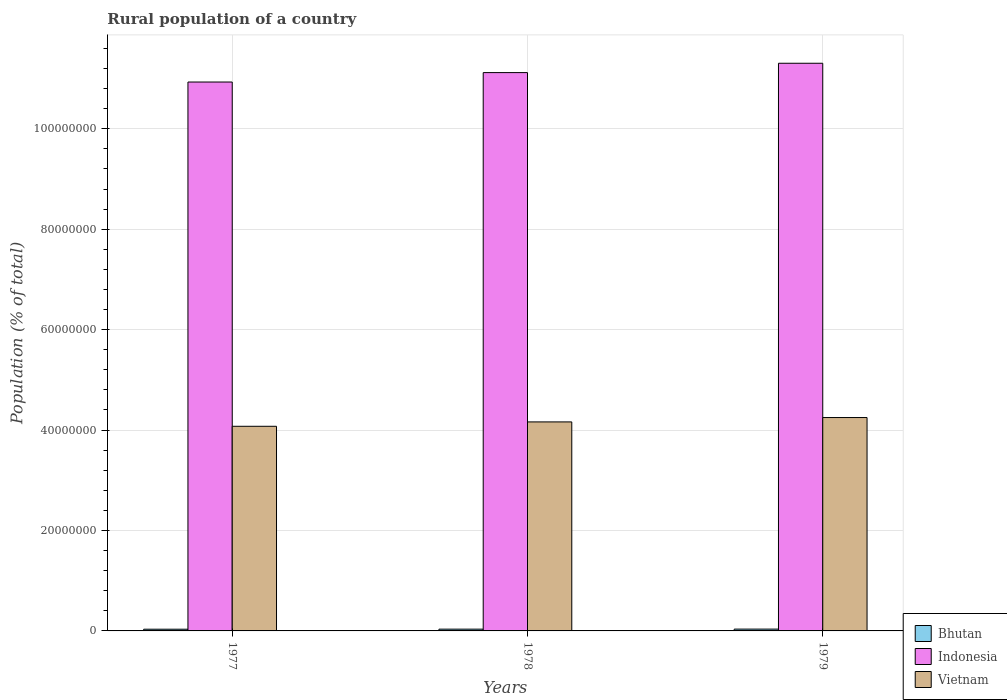How many different coloured bars are there?
Give a very brief answer. 3. How many groups of bars are there?
Give a very brief answer. 3. Are the number of bars on each tick of the X-axis equal?
Offer a very short reply. Yes. What is the label of the 2nd group of bars from the left?
Your answer should be very brief. 1978. In how many cases, is the number of bars for a given year not equal to the number of legend labels?
Offer a terse response. 0. What is the rural population in Bhutan in 1978?
Your answer should be very brief. 3.52e+05. Across all years, what is the maximum rural population in Indonesia?
Offer a very short reply. 1.13e+08. Across all years, what is the minimum rural population in Indonesia?
Provide a short and direct response. 1.09e+08. In which year was the rural population in Vietnam maximum?
Make the answer very short. 1979. In which year was the rural population in Bhutan minimum?
Offer a terse response. 1977. What is the total rural population in Indonesia in the graph?
Provide a short and direct response. 3.34e+08. What is the difference between the rural population in Indonesia in 1977 and that in 1979?
Provide a succinct answer. -3.74e+06. What is the difference between the rural population in Bhutan in 1977 and the rural population in Indonesia in 1978?
Your response must be concise. -1.11e+08. What is the average rural population in Vietnam per year?
Your response must be concise. 4.16e+07. In the year 1979, what is the difference between the rural population in Bhutan and rural population in Indonesia?
Keep it short and to the point. -1.13e+08. What is the ratio of the rural population in Bhutan in 1977 to that in 1978?
Keep it short and to the point. 0.97. Is the rural population in Vietnam in 1977 less than that in 1978?
Your answer should be compact. Yes. What is the difference between the highest and the second highest rural population in Bhutan?
Keep it short and to the point. 9602. What is the difference between the highest and the lowest rural population in Bhutan?
Your answer should be compact. 1.97e+04. What does the 3rd bar from the left in 1978 represents?
Offer a very short reply. Vietnam. How many years are there in the graph?
Give a very brief answer. 3. Does the graph contain any zero values?
Offer a very short reply. No. Does the graph contain grids?
Make the answer very short. Yes. How many legend labels are there?
Make the answer very short. 3. What is the title of the graph?
Offer a very short reply. Rural population of a country. Does "Cuba" appear as one of the legend labels in the graph?
Your answer should be very brief. No. What is the label or title of the X-axis?
Provide a succinct answer. Years. What is the label or title of the Y-axis?
Offer a terse response. Population (% of total). What is the Population (% of total) of Bhutan in 1977?
Keep it short and to the point. 3.42e+05. What is the Population (% of total) of Indonesia in 1977?
Ensure brevity in your answer.  1.09e+08. What is the Population (% of total) in Vietnam in 1977?
Make the answer very short. 4.08e+07. What is the Population (% of total) of Bhutan in 1978?
Your answer should be compact. 3.52e+05. What is the Population (% of total) in Indonesia in 1978?
Provide a short and direct response. 1.11e+08. What is the Population (% of total) of Vietnam in 1978?
Give a very brief answer. 4.16e+07. What is the Population (% of total) in Bhutan in 1979?
Ensure brevity in your answer.  3.62e+05. What is the Population (% of total) of Indonesia in 1979?
Provide a succinct answer. 1.13e+08. What is the Population (% of total) in Vietnam in 1979?
Provide a succinct answer. 4.25e+07. Across all years, what is the maximum Population (% of total) of Bhutan?
Provide a succinct answer. 3.62e+05. Across all years, what is the maximum Population (% of total) of Indonesia?
Provide a short and direct response. 1.13e+08. Across all years, what is the maximum Population (% of total) in Vietnam?
Your response must be concise. 4.25e+07. Across all years, what is the minimum Population (% of total) of Bhutan?
Ensure brevity in your answer.  3.42e+05. Across all years, what is the minimum Population (% of total) in Indonesia?
Give a very brief answer. 1.09e+08. Across all years, what is the minimum Population (% of total) of Vietnam?
Your response must be concise. 4.08e+07. What is the total Population (% of total) in Bhutan in the graph?
Offer a very short reply. 1.06e+06. What is the total Population (% of total) of Indonesia in the graph?
Provide a short and direct response. 3.34e+08. What is the total Population (% of total) in Vietnam in the graph?
Give a very brief answer. 1.25e+08. What is the difference between the Population (% of total) in Bhutan in 1977 and that in 1978?
Your answer should be very brief. -1.01e+04. What is the difference between the Population (% of total) in Indonesia in 1977 and that in 1978?
Provide a short and direct response. -1.88e+06. What is the difference between the Population (% of total) in Vietnam in 1977 and that in 1978?
Your answer should be very brief. -8.74e+05. What is the difference between the Population (% of total) of Bhutan in 1977 and that in 1979?
Keep it short and to the point. -1.97e+04. What is the difference between the Population (% of total) in Indonesia in 1977 and that in 1979?
Your response must be concise. -3.74e+06. What is the difference between the Population (% of total) of Vietnam in 1977 and that in 1979?
Make the answer very short. -1.74e+06. What is the difference between the Population (% of total) of Bhutan in 1978 and that in 1979?
Offer a very short reply. -9602. What is the difference between the Population (% of total) of Indonesia in 1978 and that in 1979?
Offer a terse response. -1.86e+06. What is the difference between the Population (% of total) in Vietnam in 1978 and that in 1979?
Provide a short and direct response. -8.69e+05. What is the difference between the Population (% of total) in Bhutan in 1977 and the Population (% of total) in Indonesia in 1978?
Your answer should be compact. -1.11e+08. What is the difference between the Population (% of total) of Bhutan in 1977 and the Population (% of total) of Vietnam in 1978?
Keep it short and to the point. -4.13e+07. What is the difference between the Population (% of total) of Indonesia in 1977 and the Population (% of total) of Vietnam in 1978?
Your answer should be very brief. 6.77e+07. What is the difference between the Population (% of total) in Bhutan in 1977 and the Population (% of total) in Indonesia in 1979?
Provide a short and direct response. -1.13e+08. What is the difference between the Population (% of total) in Bhutan in 1977 and the Population (% of total) in Vietnam in 1979?
Offer a very short reply. -4.22e+07. What is the difference between the Population (% of total) of Indonesia in 1977 and the Population (% of total) of Vietnam in 1979?
Your answer should be very brief. 6.68e+07. What is the difference between the Population (% of total) of Bhutan in 1978 and the Population (% of total) of Indonesia in 1979?
Offer a terse response. -1.13e+08. What is the difference between the Population (% of total) of Bhutan in 1978 and the Population (% of total) of Vietnam in 1979?
Keep it short and to the point. -4.21e+07. What is the difference between the Population (% of total) in Indonesia in 1978 and the Population (% of total) in Vietnam in 1979?
Offer a terse response. 6.87e+07. What is the average Population (% of total) of Bhutan per year?
Ensure brevity in your answer.  3.52e+05. What is the average Population (% of total) of Indonesia per year?
Your answer should be compact. 1.11e+08. What is the average Population (% of total) of Vietnam per year?
Offer a terse response. 4.16e+07. In the year 1977, what is the difference between the Population (% of total) in Bhutan and Population (% of total) in Indonesia?
Your answer should be very brief. -1.09e+08. In the year 1977, what is the difference between the Population (% of total) of Bhutan and Population (% of total) of Vietnam?
Make the answer very short. -4.04e+07. In the year 1977, what is the difference between the Population (% of total) in Indonesia and Population (% of total) in Vietnam?
Give a very brief answer. 6.86e+07. In the year 1978, what is the difference between the Population (% of total) of Bhutan and Population (% of total) of Indonesia?
Provide a short and direct response. -1.11e+08. In the year 1978, what is the difference between the Population (% of total) of Bhutan and Population (% of total) of Vietnam?
Your answer should be very brief. -4.13e+07. In the year 1978, what is the difference between the Population (% of total) in Indonesia and Population (% of total) in Vietnam?
Give a very brief answer. 6.96e+07. In the year 1979, what is the difference between the Population (% of total) in Bhutan and Population (% of total) in Indonesia?
Your answer should be very brief. -1.13e+08. In the year 1979, what is the difference between the Population (% of total) of Bhutan and Population (% of total) of Vietnam?
Provide a short and direct response. -4.21e+07. In the year 1979, what is the difference between the Population (% of total) of Indonesia and Population (% of total) of Vietnam?
Give a very brief answer. 7.06e+07. What is the ratio of the Population (% of total) of Bhutan in 1977 to that in 1978?
Provide a succinct answer. 0.97. What is the ratio of the Population (% of total) in Indonesia in 1977 to that in 1978?
Give a very brief answer. 0.98. What is the ratio of the Population (% of total) of Vietnam in 1977 to that in 1978?
Give a very brief answer. 0.98. What is the ratio of the Population (% of total) in Bhutan in 1977 to that in 1979?
Provide a short and direct response. 0.95. What is the ratio of the Population (% of total) in Indonesia in 1977 to that in 1979?
Provide a succinct answer. 0.97. What is the ratio of the Population (% of total) of Bhutan in 1978 to that in 1979?
Your answer should be compact. 0.97. What is the ratio of the Population (% of total) in Indonesia in 1978 to that in 1979?
Your answer should be very brief. 0.98. What is the ratio of the Population (% of total) of Vietnam in 1978 to that in 1979?
Give a very brief answer. 0.98. What is the difference between the highest and the second highest Population (% of total) in Bhutan?
Your answer should be very brief. 9602. What is the difference between the highest and the second highest Population (% of total) of Indonesia?
Your response must be concise. 1.86e+06. What is the difference between the highest and the second highest Population (% of total) of Vietnam?
Make the answer very short. 8.69e+05. What is the difference between the highest and the lowest Population (% of total) of Bhutan?
Provide a short and direct response. 1.97e+04. What is the difference between the highest and the lowest Population (% of total) in Indonesia?
Your answer should be compact. 3.74e+06. What is the difference between the highest and the lowest Population (% of total) in Vietnam?
Provide a short and direct response. 1.74e+06. 